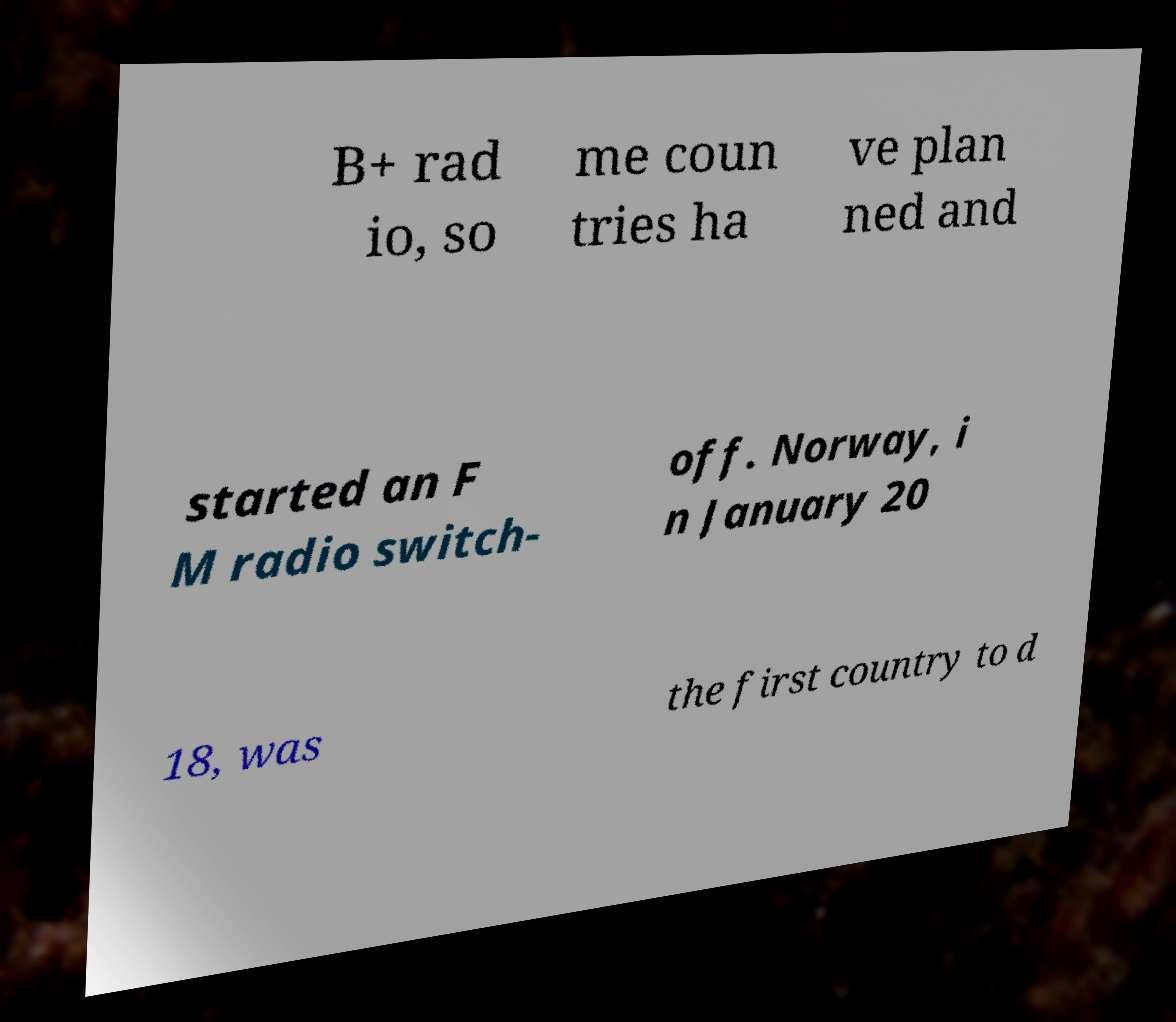Please read and relay the text visible in this image. What does it say? B+ rad io, so me coun tries ha ve plan ned and started an F M radio switch- off. Norway, i n January 20 18, was the first country to d 